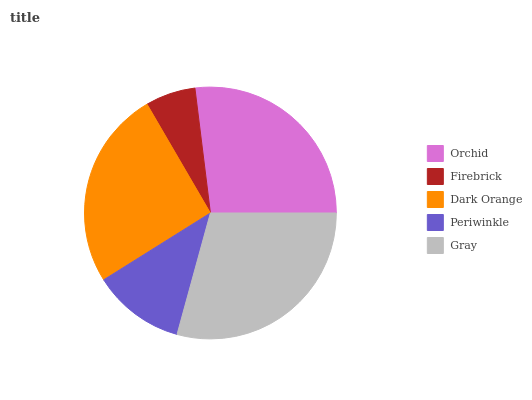Is Firebrick the minimum?
Answer yes or no. Yes. Is Gray the maximum?
Answer yes or no. Yes. Is Dark Orange the minimum?
Answer yes or no. No. Is Dark Orange the maximum?
Answer yes or no. No. Is Dark Orange greater than Firebrick?
Answer yes or no. Yes. Is Firebrick less than Dark Orange?
Answer yes or no. Yes. Is Firebrick greater than Dark Orange?
Answer yes or no. No. Is Dark Orange less than Firebrick?
Answer yes or no. No. Is Dark Orange the high median?
Answer yes or no. Yes. Is Dark Orange the low median?
Answer yes or no. Yes. Is Periwinkle the high median?
Answer yes or no. No. Is Orchid the low median?
Answer yes or no. No. 